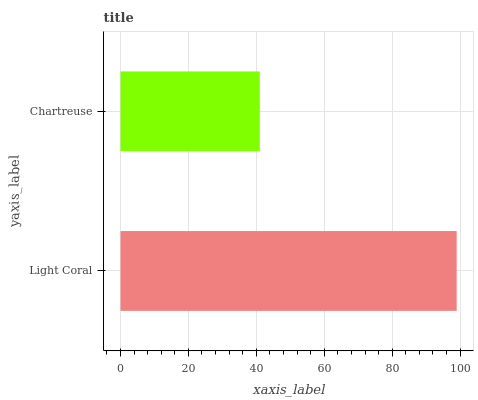Is Chartreuse the minimum?
Answer yes or no. Yes. Is Light Coral the maximum?
Answer yes or no. Yes. Is Chartreuse the maximum?
Answer yes or no. No. Is Light Coral greater than Chartreuse?
Answer yes or no. Yes. Is Chartreuse less than Light Coral?
Answer yes or no. Yes. Is Chartreuse greater than Light Coral?
Answer yes or no. No. Is Light Coral less than Chartreuse?
Answer yes or no. No. Is Light Coral the high median?
Answer yes or no. Yes. Is Chartreuse the low median?
Answer yes or no. Yes. Is Chartreuse the high median?
Answer yes or no. No. Is Light Coral the low median?
Answer yes or no. No. 